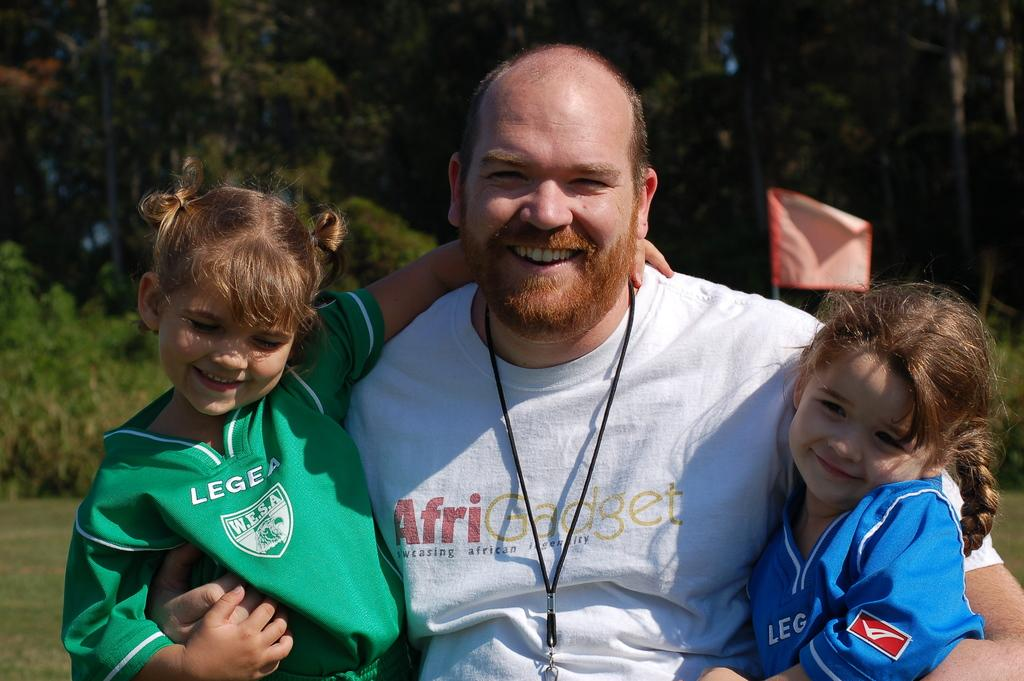<image>
Relay a brief, clear account of the picture shown. A man, wearing an Afri Gadget t-shirt, is holding two young girls. 